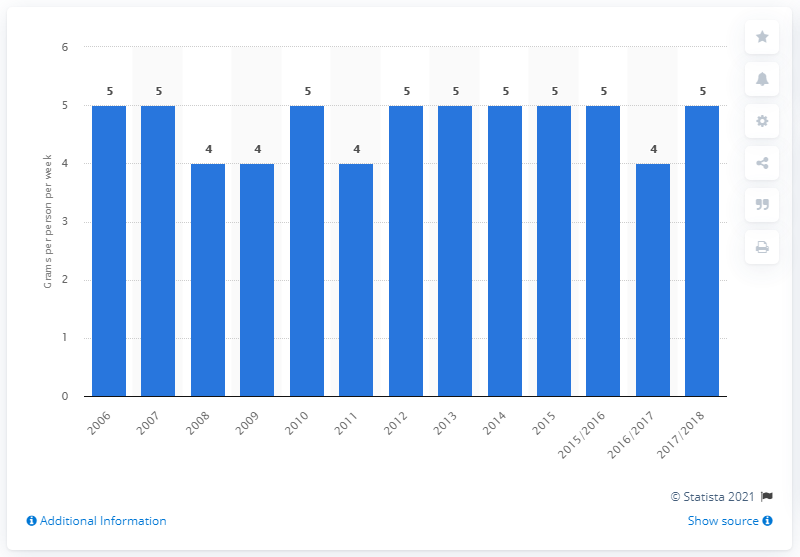Point out several critical features in this image. In the United Kingdom, cottage cheese was last purchased in 2006. 